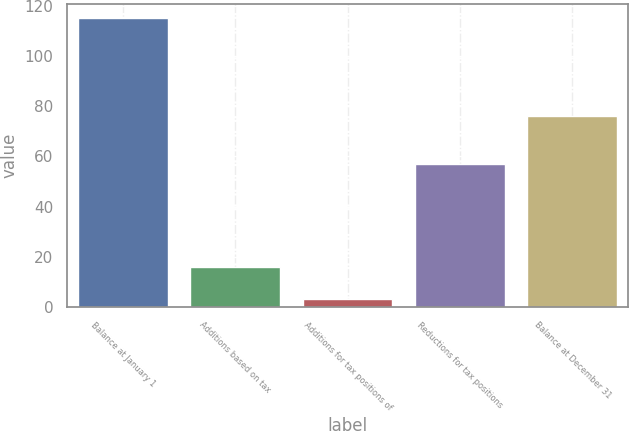Convert chart. <chart><loc_0><loc_0><loc_500><loc_500><bar_chart><fcel>Balance at January 1<fcel>Additions based on tax<fcel>Additions for tax positions of<fcel>Reductions for tax positions<fcel>Balance at December 31<nl><fcel>115<fcel>16<fcel>3<fcel>57<fcel>76<nl></chart> 